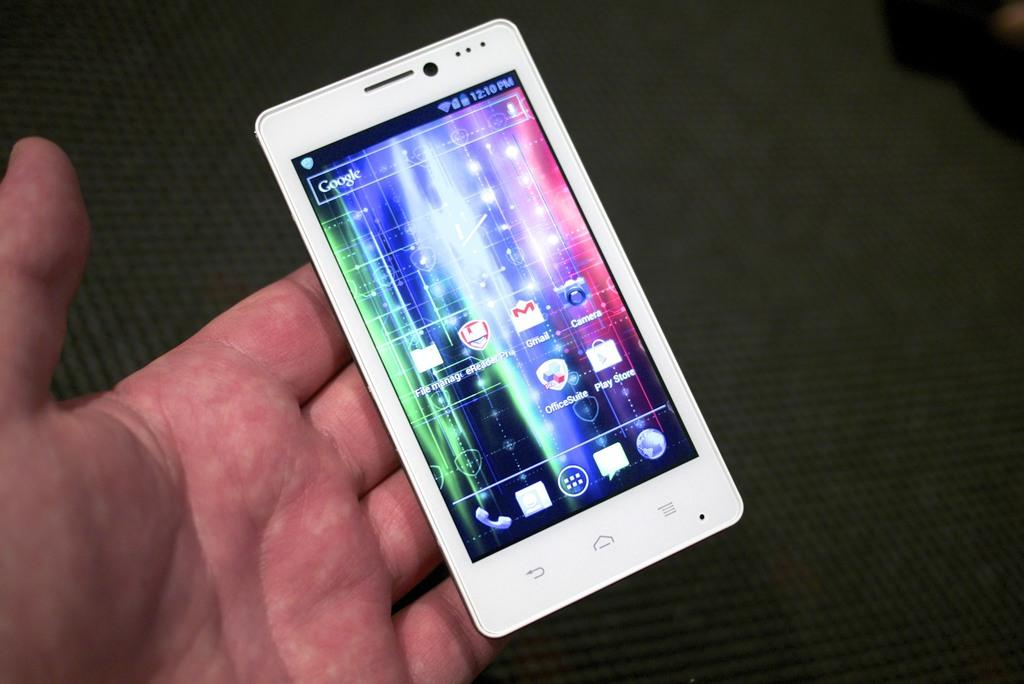What is the person in the image holding? There is a hand holding a mobile phone in the image. What can be inferred about the lighting in the image? The background of the image is black, which suggests that the lighting may be dim or the image may have been taken in low light conditions. What direction is the market moving in the image? There is no market present in the image; it only features a hand holding a mobile phone against a black background. 